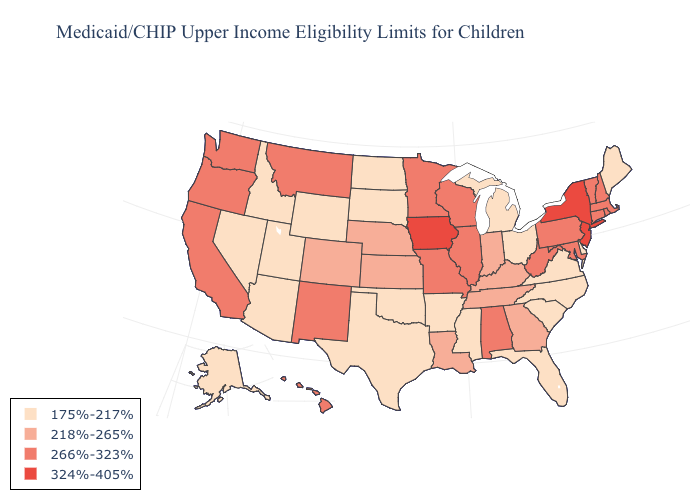What is the highest value in states that border Oregon?
Be succinct. 266%-323%. What is the value of Pennsylvania?
Concise answer only. 266%-323%. Does Alaska have the highest value in the USA?
Keep it brief. No. Name the states that have a value in the range 266%-323%?
Write a very short answer. Alabama, California, Connecticut, Hawaii, Illinois, Maryland, Massachusetts, Minnesota, Missouri, Montana, New Hampshire, New Mexico, Oregon, Pennsylvania, Rhode Island, Vermont, Washington, West Virginia, Wisconsin. Name the states that have a value in the range 266%-323%?
Keep it brief. Alabama, California, Connecticut, Hawaii, Illinois, Maryland, Massachusetts, Minnesota, Missouri, Montana, New Hampshire, New Mexico, Oregon, Pennsylvania, Rhode Island, Vermont, Washington, West Virginia, Wisconsin. Among the states that border Utah , which have the lowest value?
Answer briefly. Arizona, Idaho, Nevada, Wyoming. Name the states that have a value in the range 266%-323%?
Concise answer only. Alabama, California, Connecticut, Hawaii, Illinois, Maryland, Massachusetts, Minnesota, Missouri, Montana, New Hampshire, New Mexico, Oregon, Pennsylvania, Rhode Island, Vermont, Washington, West Virginia, Wisconsin. What is the value of Nebraska?
Give a very brief answer. 218%-265%. Is the legend a continuous bar?
Quick response, please. No. Does South Carolina have the lowest value in the USA?
Write a very short answer. Yes. Name the states that have a value in the range 218%-265%?
Write a very short answer. Colorado, Georgia, Indiana, Kansas, Kentucky, Louisiana, Nebraska, Tennessee. Name the states that have a value in the range 266%-323%?
Give a very brief answer. Alabama, California, Connecticut, Hawaii, Illinois, Maryland, Massachusetts, Minnesota, Missouri, Montana, New Hampshire, New Mexico, Oregon, Pennsylvania, Rhode Island, Vermont, Washington, West Virginia, Wisconsin. What is the value of Vermont?
Concise answer only. 266%-323%. Which states have the lowest value in the South?
Be succinct. Arkansas, Delaware, Florida, Mississippi, North Carolina, Oklahoma, South Carolina, Texas, Virginia. Name the states that have a value in the range 218%-265%?
Keep it brief. Colorado, Georgia, Indiana, Kansas, Kentucky, Louisiana, Nebraska, Tennessee. 